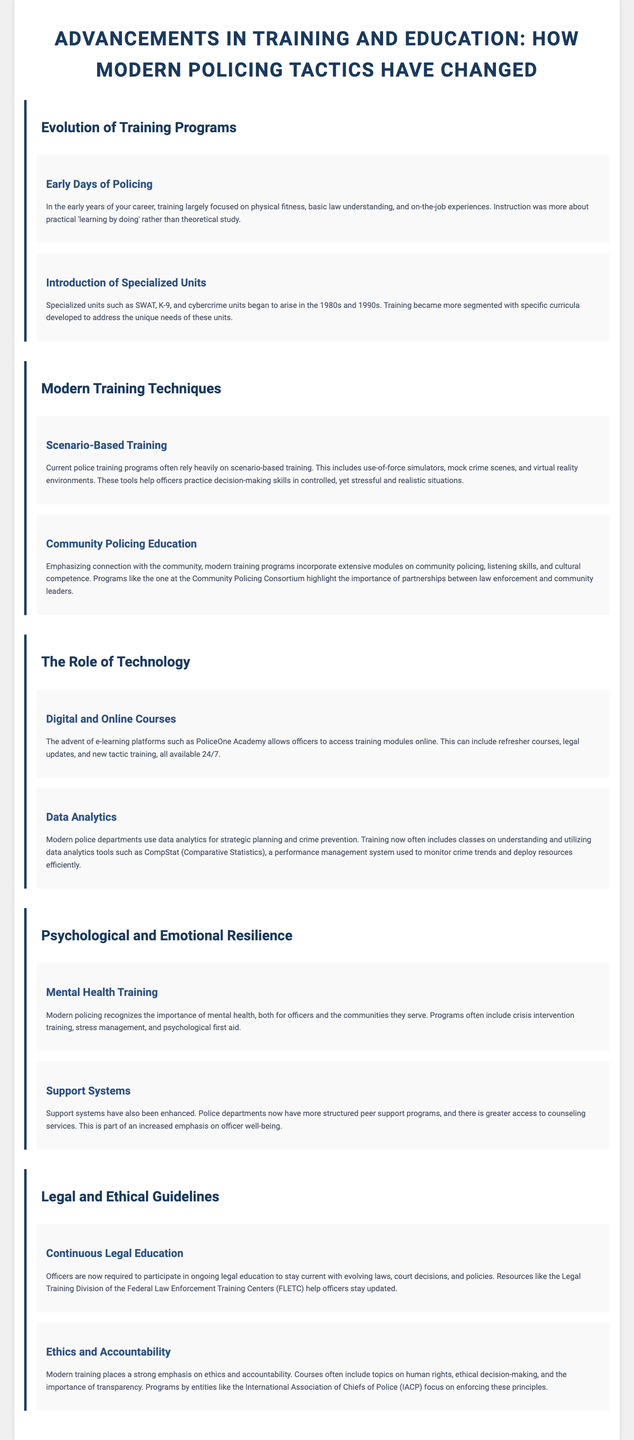what decade did specialized units begin to arise? The document states that specialized units began to arise in the 1980s and 1990s.
Answer: 1980s and 1990s what is a modern training technique mentioned in the document? The document lists scenario-based training as a current technique used in police training programs.
Answer: Scenario-based training which platform provides online training for officers? The document mentions PoliceOne Academy as an e-learning platform for officer training.
Answer: PoliceOne Academy what is the focus of community policing education? Modern training programs emphasize connection with the community, highlighted in the document.
Answer: Connection with the community how has mental health training evolved in modern policing? The document notes that modern policing includes crisis intervention training and stress management as part of mental health training.
Answer: Crisis intervention training and stress management what is emphasized alongside ethics in modern police training? The document states that accountability is strongly emphasized alongside ethics in modern training.
Answer: Accountability who provides resources for continuous legal education? The document identifies the Legal Training Division of the Federal Law Enforcement Training Centers (FLETC) as a resource for ongoing legal education.
Answer: Legal Training Division of the FLETC what role does data analytics play in modern policing? The document explains that data analytics is used for strategic planning and crime prevention in modern police departments.
Answer: Strategic planning and crime prevention 